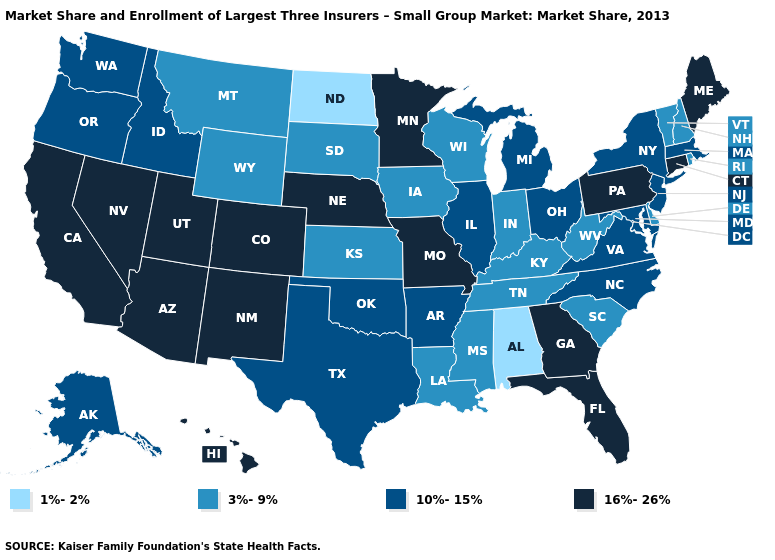Name the states that have a value in the range 10%-15%?
Concise answer only. Alaska, Arkansas, Idaho, Illinois, Maryland, Massachusetts, Michigan, New Jersey, New York, North Carolina, Ohio, Oklahoma, Oregon, Texas, Virginia, Washington. What is the value of South Dakota?
Answer briefly. 3%-9%. Name the states that have a value in the range 3%-9%?
Answer briefly. Delaware, Indiana, Iowa, Kansas, Kentucky, Louisiana, Mississippi, Montana, New Hampshire, Rhode Island, South Carolina, South Dakota, Tennessee, Vermont, West Virginia, Wisconsin, Wyoming. Does Nebraska have a lower value than Kansas?
Be succinct. No. Does the map have missing data?
Concise answer only. No. Which states have the highest value in the USA?
Write a very short answer. Arizona, California, Colorado, Connecticut, Florida, Georgia, Hawaii, Maine, Minnesota, Missouri, Nebraska, Nevada, New Mexico, Pennsylvania, Utah. Which states have the lowest value in the USA?
Keep it brief. Alabama, North Dakota. What is the lowest value in the USA?
Concise answer only. 1%-2%. What is the lowest value in the MidWest?
Answer briefly. 1%-2%. Does Vermont have a higher value than Wisconsin?
Write a very short answer. No. Name the states that have a value in the range 1%-2%?
Quick response, please. Alabama, North Dakota. What is the value of Maryland?
Short answer required. 10%-15%. What is the value of Pennsylvania?
Concise answer only. 16%-26%. What is the value of Oregon?
Keep it brief. 10%-15%. 